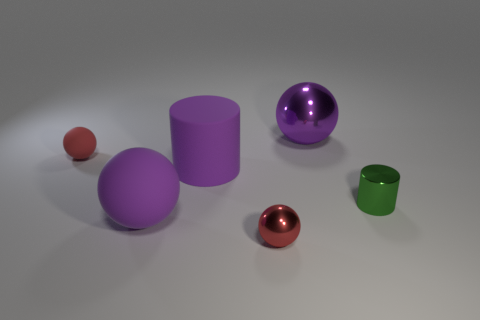What is the shape of the big purple metal thing?
Make the answer very short. Sphere. What is the material of the purple cylinder that is the same size as the purple matte ball?
Your answer should be compact. Rubber. Is there any other thing that has the same size as the purple rubber cylinder?
Your response must be concise. Yes. How many things are either small cyan shiny blocks or tiny red balls that are in front of the purple matte cylinder?
Ensure brevity in your answer.  1. The red object that is the same material as the green cylinder is what size?
Keep it short and to the point. Small. There is a purple matte thing that is on the right side of the large purple thing on the left side of the big cylinder; what is its shape?
Ensure brevity in your answer.  Cylinder. How big is the metallic thing that is behind the large rubber ball and on the left side of the tiny cylinder?
Your answer should be compact. Large. Is there a green matte thing that has the same shape as the green metallic object?
Make the answer very short. No. Is there anything else that is the same shape as the green metal object?
Your response must be concise. Yes. There is a purple sphere that is behind the red object behind the small red sphere that is in front of the big purple matte cylinder; what is its material?
Offer a very short reply. Metal. 